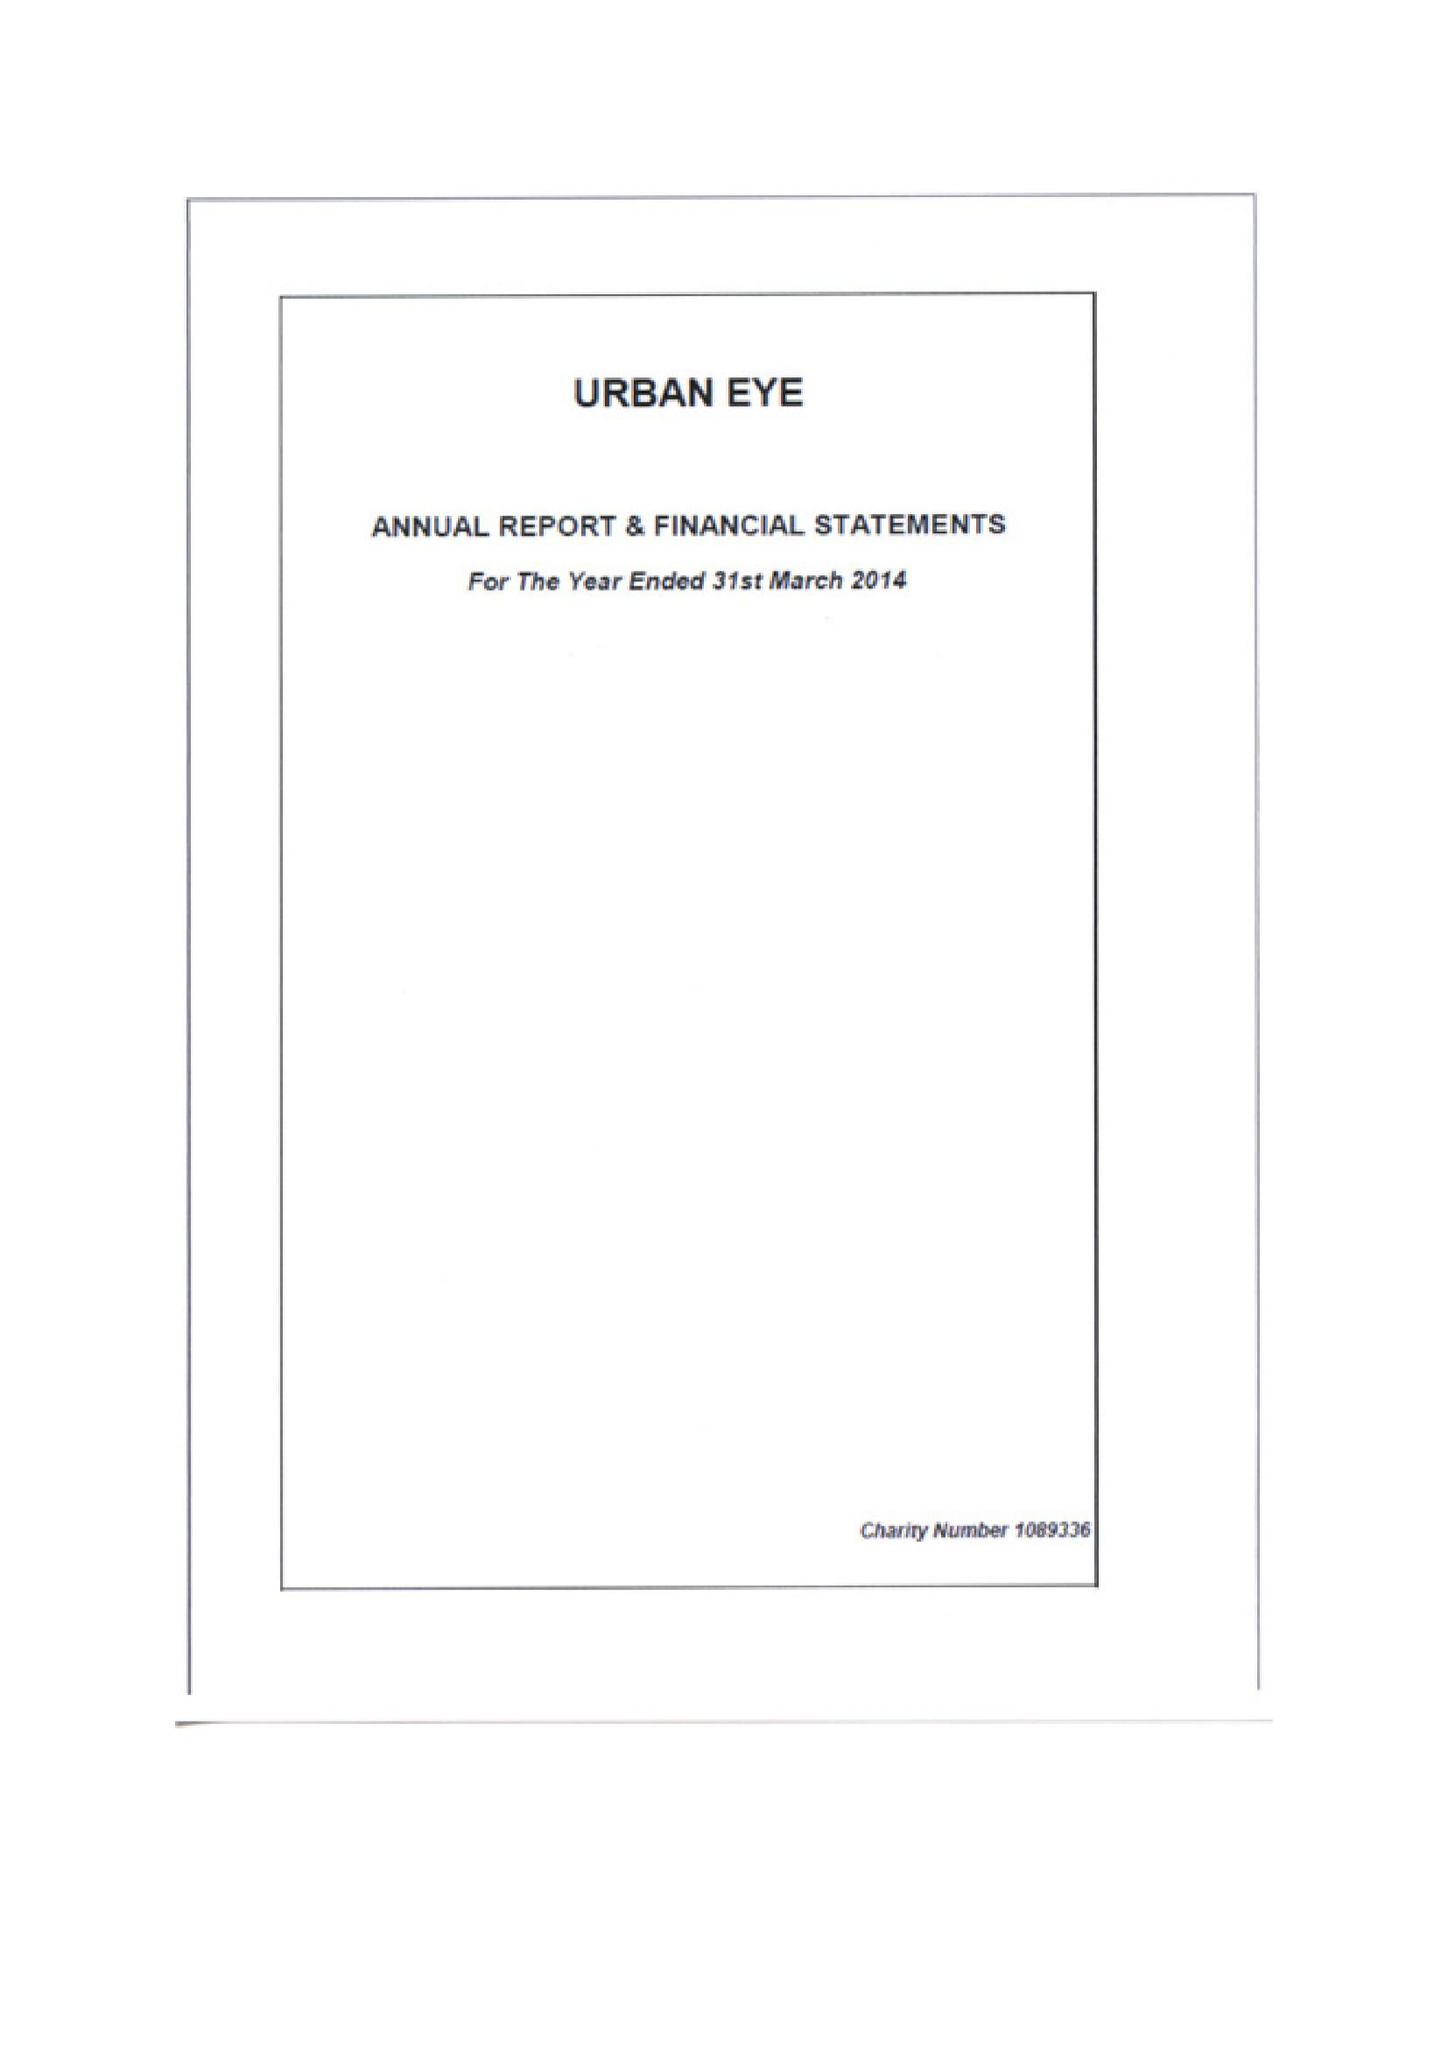What is the value for the address__post_town?
Answer the question using a single word or phrase. LONDON 